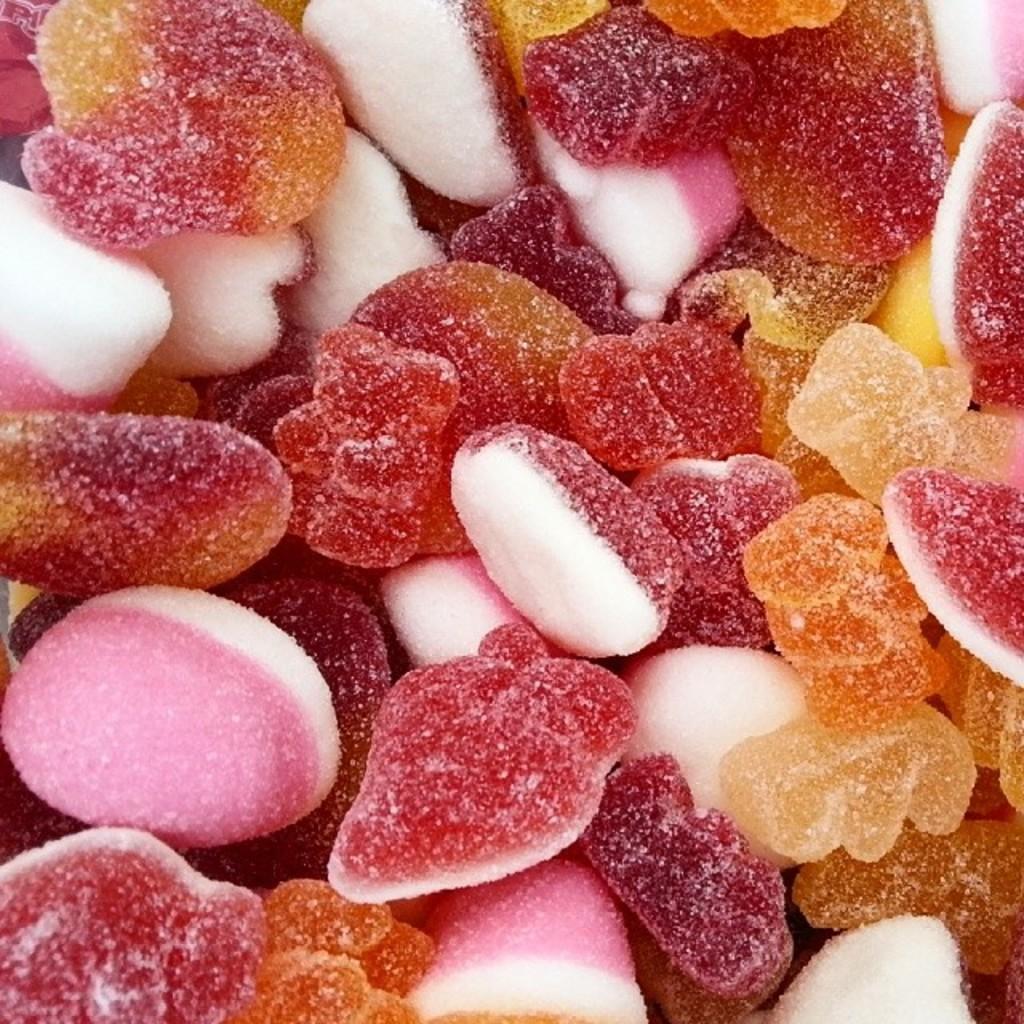Describe this image in one or two sentences. this picture is consists of candies in the image. 